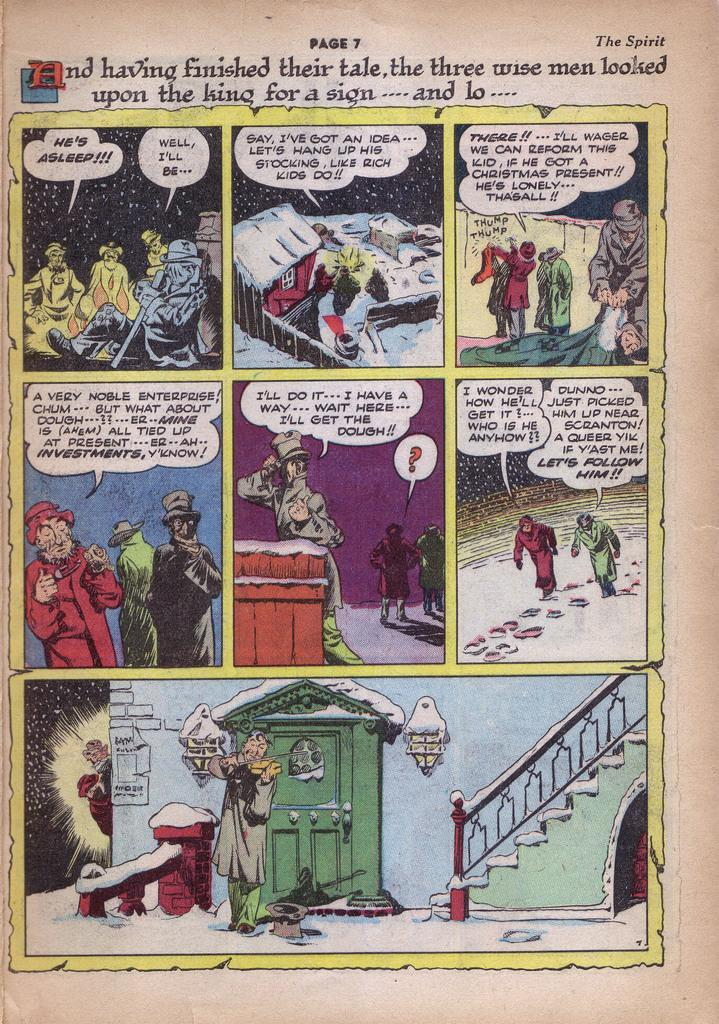Provide a one-sentence caption for the provided image. A page seven of a comic book called The Spirit. 